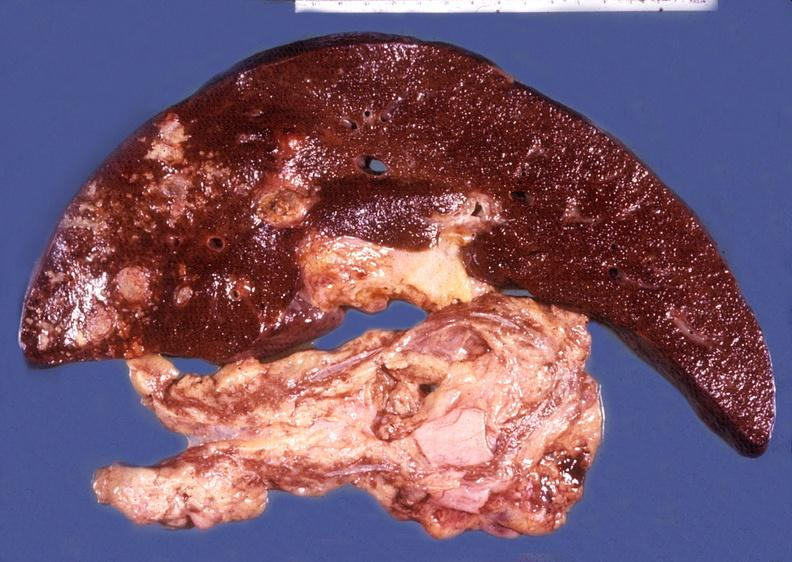s hepatobiliary present?
Answer the question using a single word or phrase. Yes 